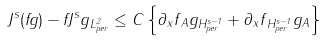Convert formula to latex. <formula><loc_0><loc_0><loc_500><loc_500>\| J ^ { s } ( f g ) - f J ^ { s } g \| _ { L _ { p e r } ^ { 2 } } \leq C \left \{ \| \partial _ { x } f \| _ { A } \| g \| _ { H _ { p e r } ^ { s - 1 } } + \| \partial _ { x } f \| _ { H _ { p e r } ^ { s - 1 } } \| g \| _ { A } \right \}</formula> 